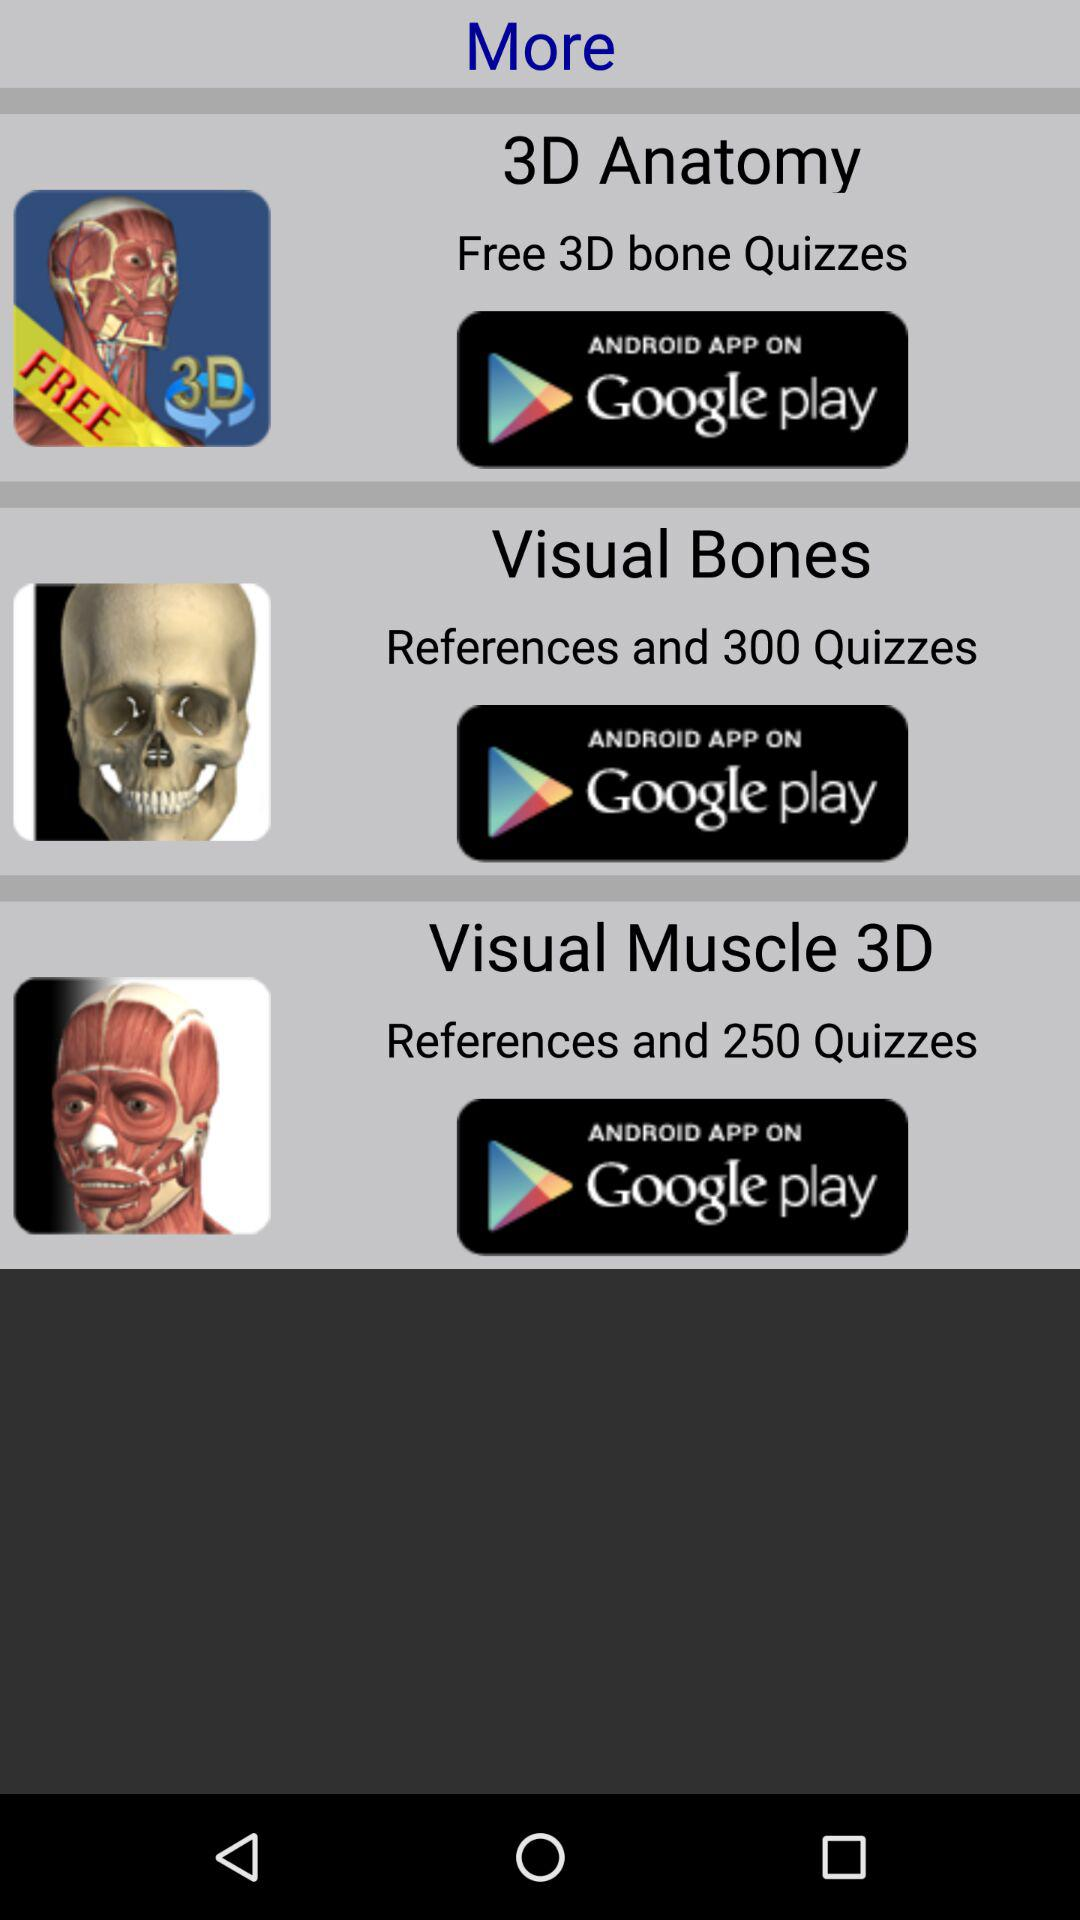What is the app name that offers free 3D bone quizzes? The app name is "3D Anatomy". 